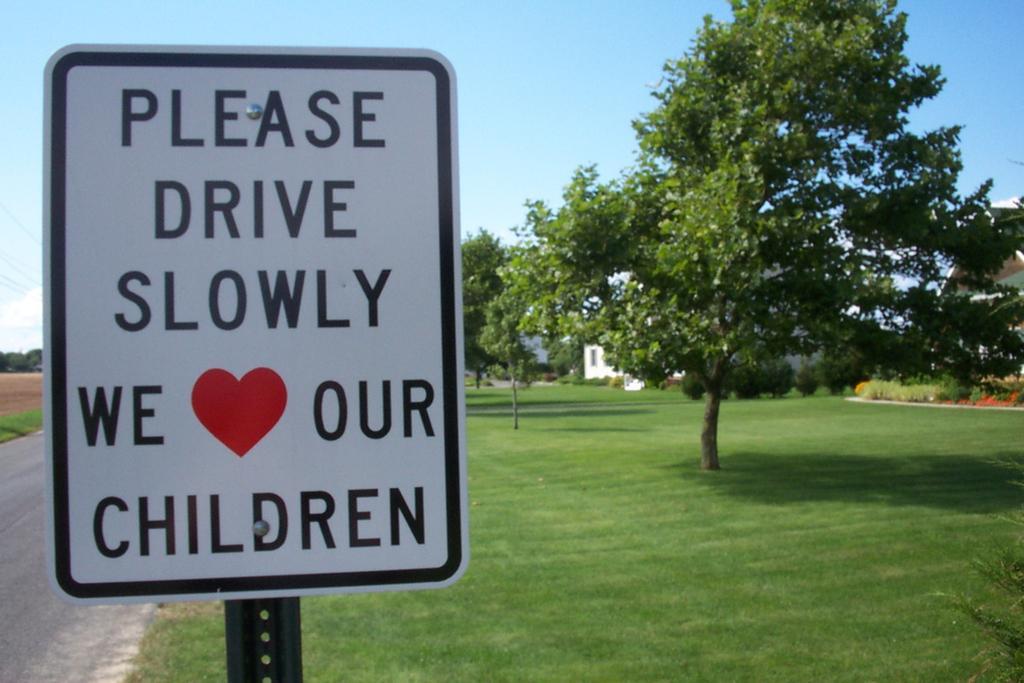In one or two sentences, can you explain what this image depicts? This image is taken outdoors. At the top of the image there is a sky with clouds. At the bottom of the image there is a road and there is a ground with grass on it. In the background there are many trees and plants and there is a house. On the left side of the image there is a board with a text on it. 